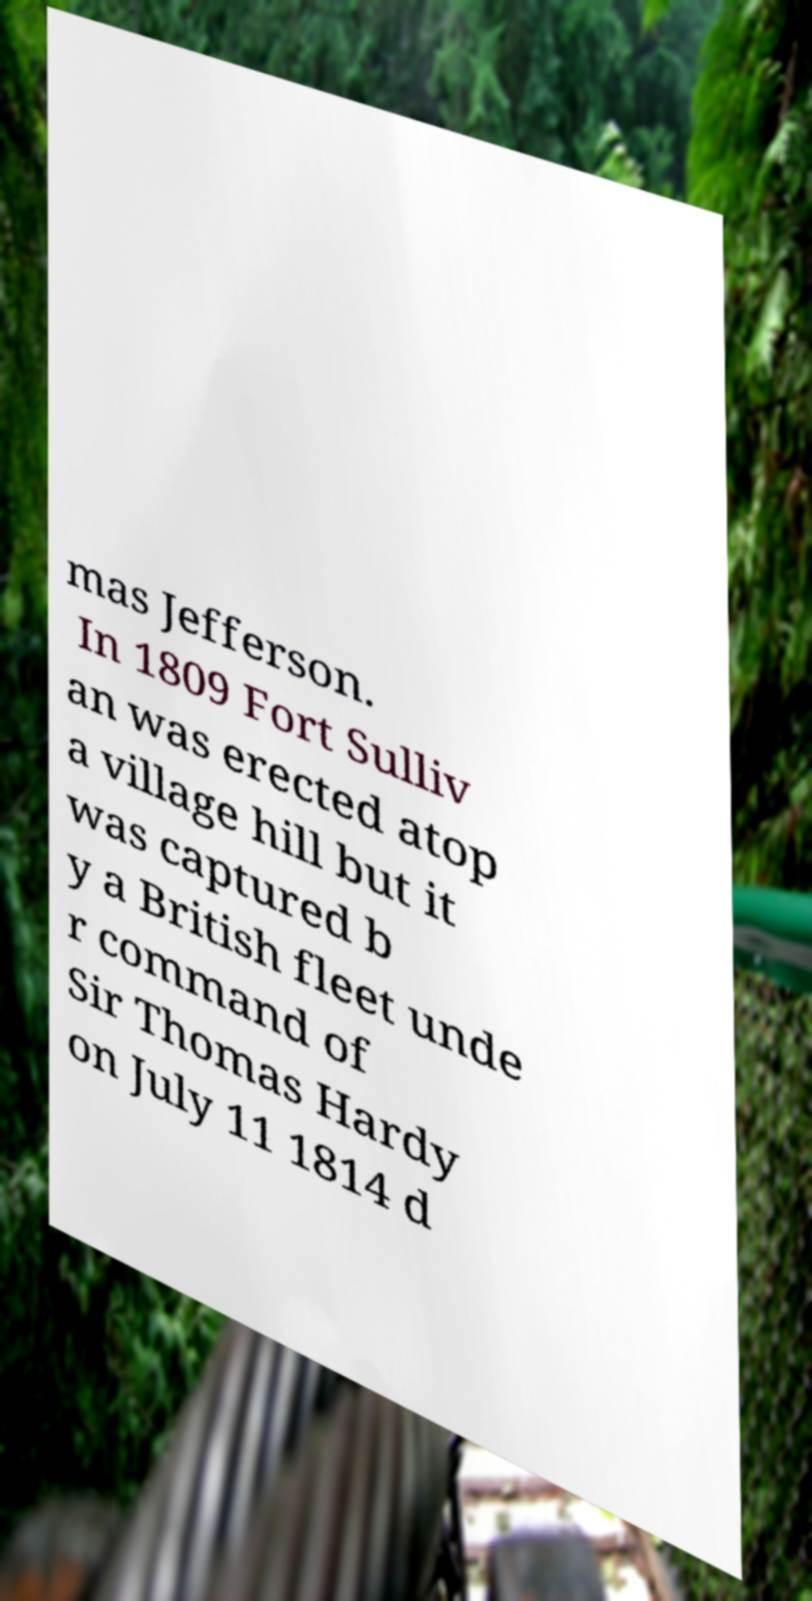Can you read and provide the text displayed in the image?This photo seems to have some interesting text. Can you extract and type it out for me? mas Jefferson. In 1809 Fort Sulliv an was erected atop a village hill but it was captured b y a British fleet unde r command of Sir Thomas Hardy on July 11 1814 d 